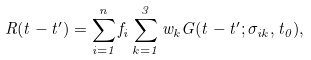<formula> <loc_0><loc_0><loc_500><loc_500>R ( t - t ^ { \prime } ) = \sum _ { i = 1 } ^ { n } { f _ { i } } \sum _ { k = 1 } ^ { 3 } { w _ { k } G ( t - t ^ { \prime } ; \sigma _ { i k } , t _ { 0 } ) } ,</formula> 